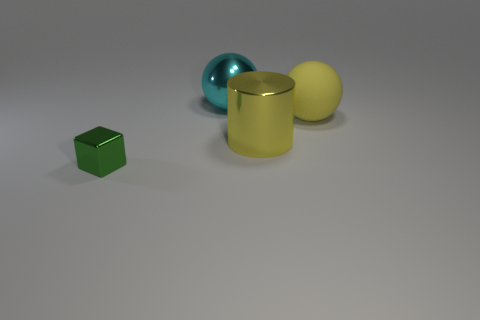Add 2 big yellow cylinders. How many objects exist? 6 Subtract 1 blocks. How many blocks are left? 0 Add 1 cyan shiny spheres. How many cyan shiny spheres exist? 2 Subtract 0 gray balls. How many objects are left? 4 Subtract all blocks. How many objects are left? 3 Subtract all green spheres. Subtract all yellow blocks. How many spheres are left? 2 Subtract all tiny blue cylinders. Subtract all big metallic cylinders. How many objects are left? 3 Add 2 large yellow rubber balls. How many large yellow rubber balls are left? 3 